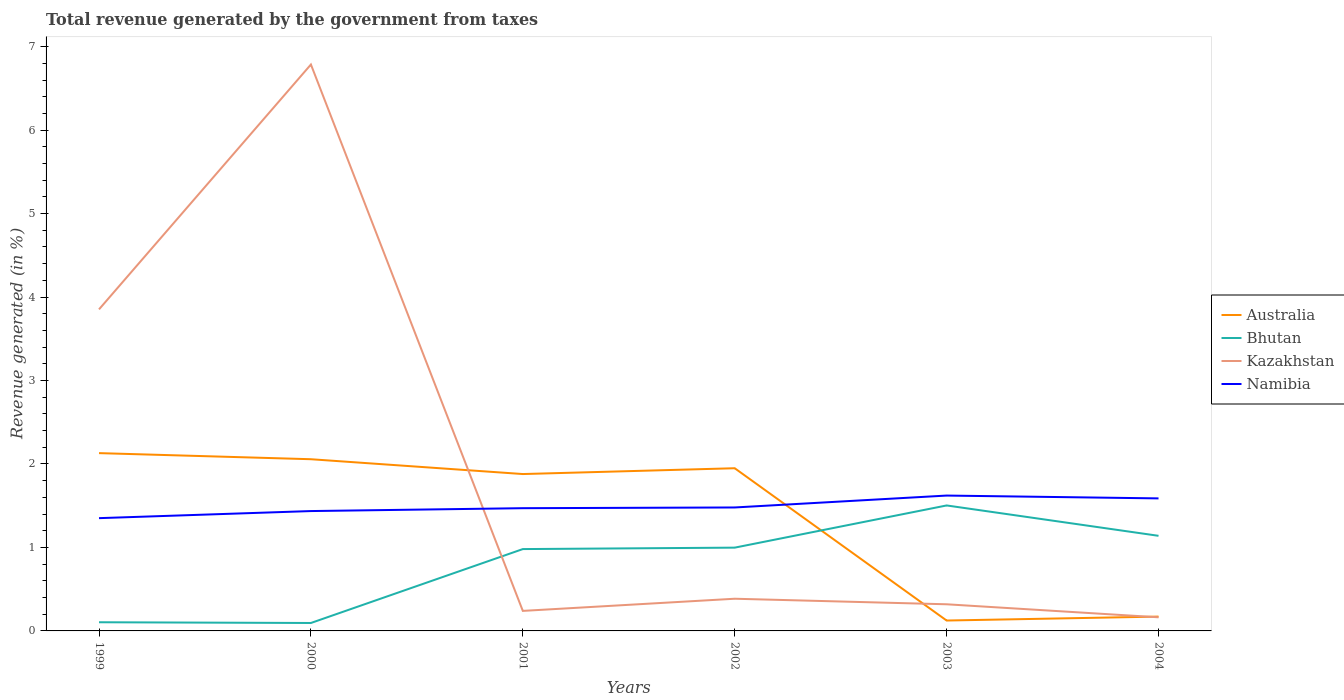Does the line corresponding to Kazakhstan intersect with the line corresponding to Bhutan?
Provide a short and direct response. Yes. Is the number of lines equal to the number of legend labels?
Make the answer very short. Yes. Across all years, what is the maximum total revenue generated in Kazakhstan?
Keep it short and to the point. 0.16. In which year was the total revenue generated in Namibia maximum?
Make the answer very short. 1999. What is the total total revenue generated in Namibia in the graph?
Provide a succinct answer. -0.12. What is the difference between the highest and the second highest total revenue generated in Kazakhstan?
Your answer should be very brief. 6.62. What is the difference between the highest and the lowest total revenue generated in Bhutan?
Offer a terse response. 4. How many lines are there?
Provide a succinct answer. 4. How many years are there in the graph?
Make the answer very short. 6. What is the difference between two consecutive major ticks on the Y-axis?
Offer a very short reply. 1. Are the values on the major ticks of Y-axis written in scientific E-notation?
Your answer should be very brief. No. Does the graph contain any zero values?
Ensure brevity in your answer.  No. Where does the legend appear in the graph?
Offer a terse response. Center right. How many legend labels are there?
Offer a terse response. 4. How are the legend labels stacked?
Your response must be concise. Vertical. What is the title of the graph?
Your answer should be very brief. Total revenue generated by the government from taxes. What is the label or title of the X-axis?
Offer a terse response. Years. What is the label or title of the Y-axis?
Offer a terse response. Revenue generated (in %). What is the Revenue generated (in %) in Australia in 1999?
Ensure brevity in your answer.  2.13. What is the Revenue generated (in %) of Bhutan in 1999?
Your response must be concise. 0.1. What is the Revenue generated (in %) of Kazakhstan in 1999?
Your response must be concise. 3.85. What is the Revenue generated (in %) of Namibia in 1999?
Provide a short and direct response. 1.35. What is the Revenue generated (in %) in Australia in 2000?
Give a very brief answer. 2.06. What is the Revenue generated (in %) of Bhutan in 2000?
Offer a very short reply. 0.1. What is the Revenue generated (in %) in Kazakhstan in 2000?
Keep it short and to the point. 6.79. What is the Revenue generated (in %) in Namibia in 2000?
Your answer should be compact. 1.44. What is the Revenue generated (in %) in Australia in 2001?
Offer a very short reply. 1.88. What is the Revenue generated (in %) of Bhutan in 2001?
Provide a short and direct response. 0.98. What is the Revenue generated (in %) in Kazakhstan in 2001?
Make the answer very short. 0.24. What is the Revenue generated (in %) of Namibia in 2001?
Give a very brief answer. 1.47. What is the Revenue generated (in %) of Australia in 2002?
Provide a succinct answer. 1.95. What is the Revenue generated (in %) of Bhutan in 2002?
Your response must be concise. 1. What is the Revenue generated (in %) of Kazakhstan in 2002?
Give a very brief answer. 0.39. What is the Revenue generated (in %) in Namibia in 2002?
Offer a terse response. 1.48. What is the Revenue generated (in %) of Australia in 2003?
Keep it short and to the point. 0.12. What is the Revenue generated (in %) in Bhutan in 2003?
Give a very brief answer. 1.5. What is the Revenue generated (in %) in Kazakhstan in 2003?
Offer a very short reply. 0.32. What is the Revenue generated (in %) in Namibia in 2003?
Your answer should be very brief. 1.62. What is the Revenue generated (in %) in Australia in 2004?
Provide a succinct answer. 0.17. What is the Revenue generated (in %) of Bhutan in 2004?
Ensure brevity in your answer.  1.14. What is the Revenue generated (in %) in Kazakhstan in 2004?
Provide a succinct answer. 0.16. What is the Revenue generated (in %) of Namibia in 2004?
Give a very brief answer. 1.59. Across all years, what is the maximum Revenue generated (in %) of Australia?
Provide a short and direct response. 2.13. Across all years, what is the maximum Revenue generated (in %) in Bhutan?
Your answer should be very brief. 1.5. Across all years, what is the maximum Revenue generated (in %) of Kazakhstan?
Offer a very short reply. 6.79. Across all years, what is the maximum Revenue generated (in %) in Namibia?
Your answer should be very brief. 1.62. Across all years, what is the minimum Revenue generated (in %) of Australia?
Provide a short and direct response. 0.12. Across all years, what is the minimum Revenue generated (in %) in Bhutan?
Ensure brevity in your answer.  0.1. Across all years, what is the minimum Revenue generated (in %) in Kazakhstan?
Your response must be concise. 0.16. Across all years, what is the minimum Revenue generated (in %) in Namibia?
Offer a very short reply. 1.35. What is the total Revenue generated (in %) in Australia in the graph?
Your answer should be very brief. 8.31. What is the total Revenue generated (in %) in Bhutan in the graph?
Your answer should be compact. 4.82. What is the total Revenue generated (in %) of Kazakhstan in the graph?
Provide a succinct answer. 11.75. What is the total Revenue generated (in %) of Namibia in the graph?
Give a very brief answer. 8.95. What is the difference between the Revenue generated (in %) in Australia in 1999 and that in 2000?
Keep it short and to the point. 0.07. What is the difference between the Revenue generated (in %) of Bhutan in 1999 and that in 2000?
Give a very brief answer. 0.01. What is the difference between the Revenue generated (in %) in Kazakhstan in 1999 and that in 2000?
Give a very brief answer. -2.93. What is the difference between the Revenue generated (in %) in Namibia in 1999 and that in 2000?
Provide a succinct answer. -0.08. What is the difference between the Revenue generated (in %) of Australia in 1999 and that in 2001?
Provide a short and direct response. 0.25. What is the difference between the Revenue generated (in %) in Bhutan in 1999 and that in 2001?
Give a very brief answer. -0.88. What is the difference between the Revenue generated (in %) in Kazakhstan in 1999 and that in 2001?
Your answer should be compact. 3.61. What is the difference between the Revenue generated (in %) in Namibia in 1999 and that in 2001?
Give a very brief answer. -0.12. What is the difference between the Revenue generated (in %) of Australia in 1999 and that in 2002?
Offer a very short reply. 0.18. What is the difference between the Revenue generated (in %) of Bhutan in 1999 and that in 2002?
Offer a terse response. -0.89. What is the difference between the Revenue generated (in %) of Kazakhstan in 1999 and that in 2002?
Your answer should be compact. 3.47. What is the difference between the Revenue generated (in %) in Namibia in 1999 and that in 2002?
Give a very brief answer. -0.13. What is the difference between the Revenue generated (in %) in Australia in 1999 and that in 2003?
Give a very brief answer. 2.01. What is the difference between the Revenue generated (in %) of Bhutan in 1999 and that in 2003?
Ensure brevity in your answer.  -1.4. What is the difference between the Revenue generated (in %) of Kazakhstan in 1999 and that in 2003?
Your answer should be very brief. 3.53. What is the difference between the Revenue generated (in %) in Namibia in 1999 and that in 2003?
Your answer should be very brief. -0.27. What is the difference between the Revenue generated (in %) of Australia in 1999 and that in 2004?
Your answer should be compact. 1.96. What is the difference between the Revenue generated (in %) of Bhutan in 1999 and that in 2004?
Provide a succinct answer. -1.04. What is the difference between the Revenue generated (in %) of Kazakhstan in 1999 and that in 2004?
Make the answer very short. 3.69. What is the difference between the Revenue generated (in %) in Namibia in 1999 and that in 2004?
Offer a very short reply. -0.24. What is the difference between the Revenue generated (in %) in Australia in 2000 and that in 2001?
Provide a short and direct response. 0.18. What is the difference between the Revenue generated (in %) of Bhutan in 2000 and that in 2001?
Ensure brevity in your answer.  -0.89. What is the difference between the Revenue generated (in %) in Kazakhstan in 2000 and that in 2001?
Provide a short and direct response. 6.55. What is the difference between the Revenue generated (in %) of Namibia in 2000 and that in 2001?
Provide a short and direct response. -0.03. What is the difference between the Revenue generated (in %) of Australia in 2000 and that in 2002?
Provide a succinct answer. 0.11. What is the difference between the Revenue generated (in %) in Bhutan in 2000 and that in 2002?
Provide a short and direct response. -0.9. What is the difference between the Revenue generated (in %) in Kazakhstan in 2000 and that in 2002?
Give a very brief answer. 6.4. What is the difference between the Revenue generated (in %) of Namibia in 2000 and that in 2002?
Provide a succinct answer. -0.04. What is the difference between the Revenue generated (in %) in Australia in 2000 and that in 2003?
Keep it short and to the point. 1.93. What is the difference between the Revenue generated (in %) of Bhutan in 2000 and that in 2003?
Offer a very short reply. -1.41. What is the difference between the Revenue generated (in %) of Kazakhstan in 2000 and that in 2003?
Offer a terse response. 6.47. What is the difference between the Revenue generated (in %) of Namibia in 2000 and that in 2003?
Your answer should be compact. -0.19. What is the difference between the Revenue generated (in %) in Australia in 2000 and that in 2004?
Your answer should be compact. 1.89. What is the difference between the Revenue generated (in %) of Bhutan in 2000 and that in 2004?
Keep it short and to the point. -1.04. What is the difference between the Revenue generated (in %) in Kazakhstan in 2000 and that in 2004?
Give a very brief answer. 6.62. What is the difference between the Revenue generated (in %) in Namibia in 2000 and that in 2004?
Keep it short and to the point. -0.15. What is the difference between the Revenue generated (in %) of Australia in 2001 and that in 2002?
Provide a short and direct response. -0.07. What is the difference between the Revenue generated (in %) of Bhutan in 2001 and that in 2002?
Your response must be concise. -0.02. What is the difference between the Revenue generated (in %) in Kazakhstan in 2001 and that in 2002?
Offer a terse response. -0.15. What is the difference between the Revenue generated (in %) in Namibia in 2001 and that in 2002?
Ensure brevity in your answer.  -0.01. What is the difference between the Revenue generated (in %) in Australia in 2001 and that in 2003?
Your answer should be very brief. 1.76. What is the difference between the Revenue generated (in %) of Bhutan in 2001 and that in 2003?
Provide a succinct answer. -0.52. What is the difference between the Revenue generated (in %) in Kazakhstan in 2001 and that in 2003?
Offer a very short reply. -0.08. What is the difference between the Revenue generated (in %) of Namibia in 2001 and that in 2003?
Your answer should be compact. -0.15. What is the difference between the Revenue generated (in %) in Australia in 2001 and that in 2004?
Keep it short and to the point. 1.71. What is the difference between the Revenue generated (in %) of Bhutan in 2001 and that in 2004?
Your response must be concise. -0.16. What is the difference between the Revenue generated (in %) of Kazakhstan in 2001 and that in 2004?
Make the answer very short. 0.08. What is the difference between the Revenue generated (in %) of Namibia in 2001 and that in 2004?
Make the answer very short. -0.12. What is the difference between the Revenue generated (in %) of Australia in 2002 and that in 2003?
Provide a succinct answer. 1.82. What is the difference between the Revenue generated (in %) in Bhutan in 2002 and that in 2003?
Offer a very short reply. -0.51. What is the difference between the Revenue generated (in %) of Kazakhstan in 2002 and that in 2003?
Your response must be concise. 0.07. What is the difference between the Revenue generated (in %) in Namibia in 2002 and that in 2003?
Offer a very short reply. -0.14. What is the difference between the Revenue generated (in %) in Australia in 2002 and that in 2004?
Provide a short and direct response. 1.78. What is the difference between the Revenue generated (in %) of Bhutan in 2002 and that in 2004?
Offer a terse response. -0.14. What is the difference between the Revenue generated (in %) of Kazakhstan in 2002 and that in 2004?
Offer a very short reply. 0.22. What is the difference between the Revenue generated (in %) of Namibia in 2002 and that in 2004?
Make the answer very short. -0.11. What is the difference between the Revenue generated (in %) of Australia in 2003 and that in 2004?
Offer a terse response. -0.05. What is the difference between the Revenue generated (in %) in Bhutan in 2003 and that in 2004?
Ensure brevity in your answer.  0.36. What is the difference between the Revenue generated (in %) in Kazakhstan in 2003 and that in 2004?
Offer a very short reply. 0.16. What is the difference between the Revenue generated (in %) of Namibia in 2003 and that in 2004?
Offer a very short reply. 0.03. What is the difference between the Revenue generated (in %) in Australia in 1999 and the Revenue generated (in %) in Bhutan in 2000?
Offer a very short reply. 2.04. What is the difference between the Revenue generated (in %) in Australia in 1999 and the Revenue generated (in %) in Kazakhstan in 2000?
Offer a terse response. -4.66. What is the difference between the Revenue generated (in %) in Australia in 1999 and the Revenue generated (in %) in Namibia in 2000?
Keep it short and to the point. 0.69. What is the difference between the Revenue generated (in %) of Bhutan in 1999 and the Revenue generated (in %) of Kazakhstan in 2000?
Offer a terse response. -6.68. What is the difference between the Revenue generated (in %) in Bhutan in 1999 and the Revenue generated (in %) in Namibia in 2000?
Give a very brief answer. -1.33. What is the difference between the Revenue generated (in %) in Kazakhstan in 1999 and the Revenue generated (in %) in Namibia in 2000?
Your response must be concise. 2.42. What is the difference between the Revenue generated (in %) of Australia in 1999 and the Revenue generated (in %) of Bhutan in 2001?
Make the answer very short. 1.15. What is the difference between the Revenue generated (in %) of Australia in 1999 and the Revenue generated (in %) of Kazakhstan in 2001?
Ensure brevity in your answer.  1.89. What is the difference between the Revenue generated (in %) of Australia in 1999 and the Revenue generated (in %) of Namibia in 2001?
Make the answer very short. 0.66. What is the difference between the Revenue generated (in %) in Bhutan in 1999 and the Revenue generated (in %) in Kazakhstan in 2001?
Ensure brevity in your answer.  -0.14. What is the difference between the Revenue generated (in %) of Bhutan in 1999 and the Revenue generated (in %) of Namibia in 2001?
Provide a short and direct response. -1.37. What is the difference between the Revenue generated (in %) of Kazakhstan in 1999 and the Revenue generated (in %) of Namibia in 2001?
Provide a short and direct response. 2.38. What is the difference between the Revenue generated (in %) in Australia in 1999 and the Revenue generated (in %) in Bhutan in 2002?
Provide a succinct answer. 1.13. What is the difference between the Revenue generated (in %) of Australia in 1999 and the Revenue generated (in %) of Kazakhstan in 2002?
Offer a very short reply. 1.74. What is the difference between the Revenue generated (in %) in Australia in 1999 and the Revenue generated (in %) in Namibia in 2002?
Make the answer very short. 0.65. What is the difference between the Revenue generated (in %) of Bhutan in 1999 and the Revenue generated (in %) of Kazakhstan in 2002?
Offer a very short reply. -0.28. What is the difference between the Revenue generated (in %) in Bhutan in 1999 and the Revenue generated (in %) in Namibia in 2002?
Your response must be concise. -1.38. What is the difference between the Revenue generated (in %) in Kazakhstan in 1999 and the Revenue generated (in %) in Namibia in 2002?
Your answer should be compact. 2.37. What is the difference between the Revenue generated (in %) of Australia in 1999 and the Revenue generated (in %) of Bhutan in 2003?
Provide a short and direct response. 0.63. What is the difference between the Revenue generated (in %) of Australia in 1999 and the Revenue generated (in %) of Kazakhstan in 2003?
Your answer should be compact. 1.81. What is the difference between the Revenue generated (in %) in Australia in 1999 and the Revenue generated (in %) in Namibia in 2003?
Offer a very short reply. 0.51. What is the difference between the Revenue generated (in %) in Bhutan in 1999 and the Revenue generated (in %) in Kazakhstan in 2003?
Your response must be concise. -0.22. What is the difference between the Revenue generated (in %) in Bhutan in 1999 and the Revenue generated (in %) in Namibia in 2003?
Your response must be concise. -1.52. What is the difference between the Revenue generated (in %) in Kazakhstan in 1999 and the Revenue generated (in %) in Namibia in 2003?
Provide a succinct answer. 2.23. What is the difference between the Revenue generated (in %) of Australia in 1999 and the Revenue generated (in %) of Bhutan in 2004?
Give a very brief answer. 0.99. What is the difference between the Revenue generated (in %) of Australia in 1999 and the Revenue generated (in %) of Kazakhstan in 2004?
Make the answer very short. 1.97. What is the difference between the Revenue generated (in %) of Australia in 1999 and the Revenue generated (in %) of Namibia in 2004?
Provide a short and direct response. 0.54. What is the difference between the Revenue generated (in %) in Bhutan in 1999 and the Revenue generated (in %) in Kazakhstan in 2004?
Ensure brevity in your answer.  -0.06. What is the difference between the Revenue generated (in %) in Bhutan in 1999 and the Revenue generated (in %) in Namibia in 2004?
Provide a succinct answer. -1.48. What is the difference between the Revenue generated (in %) in Kazakhstan in 1999 and the Revenue generated (in %) in Namibia in 2004?
Make the answer very short. 2.26. What is the difference between the Revenue generated (in %) in Australia in 2000 and the Revenue generated (in %) in Bhutan in 2001?
Your response must be concise. 1.08. What is the difference between the Revenue generated (in %) of Australia in 2000 and the Revenue generated (in %) of Kazakhstan in 2001?
Your answer should be very brief. 1.82. What is the difference between the Revenue generated (in %) in Australia in 2000 and the Revenue generated (in %) in Namibia in 2001?
Offer a terse response. 0.59. What is the difference between the Revenue generated (in %) of Bhutan in 2000 and the Revenue generated (in %) of Kazakhstan in 2001?
Provide a succinct answer. -0.14. What is the difference between the Revenue generated (in %) of Bhutan in 2000 and the Revenue generated (in %) of Namibia in 2001?
Give a very brief answer. -1.38. What is the difference between the Revenue generated (in %) in Kazakhstan in 2000 and the Revenue generated (in %) in Namibia in 2001?
Provide a short and direct response. 5.32. What is the difference between the Revenue generated (in %) in Australia in 2000 and the Revenue generated (in %) in Bhutan in 2002?
Your response must be concise. 1.06. What is the difference between the Revenue generated (in %) of Australia in 2000 and the Revenue generated (in %) of Kazakhstan in 2002?
Your answer should be very brief. 1.67. What is the difference between the Revenue generated (in %) in Australia in 2000 and the Revenue generated (in %) in Namibia in 2002?
Give a very brief answer. 0.58. What is the difference between the Revenue generated (in %) in Bhutan in 2000 and the Revenue generated (in %) in Kazakhstan in 2002?
Your response must be concise. -0.29. What is the difference between the Revenue generated (in %) of Bhutan in 2000 and the Revenue generated (in %) of Namibia in 2002?
Provide a succinct answer. -1.38. What is the difference between the Revenue generated (in %) of Kazakhstan in 2000 and the Revenue generated (in %) of Namibia in 2002?
Your response must be concise. 5.31. What is the difference between the Revenue generated (in %) of Australia in 2000 and the Revenue generated (in %) of Bhutan in 2003?
Make the answer very short. 0.55. What is the difference between the Revenue generated (in %) in Australia in 2000 and the Revenue generated (in %) in Kazakhstan in 2003?
Give a very brief answer. 1.74. What is the difference between the Revenue generated (in %) of Australia in 2000 and the Revenue generated (in %) of Namibia in 2003?
Ensure brevity in your answer.  0.44. What is the difference between the Revenue generated (in %) in Bhutan in 2000 and the Revenue generated (in %) in Kazakhstan in 2003?
Keep it short and to the point. -0.22. What is the difference between the Revenue generated (in %) of Bhutan in 2000 and the Revenue generated (in %) of Namibia in 2003?
Your answer should be very brief. -1.53. What is the difference between the Revenue generated (in %) in Kazakhstan in 2000 and the Revenue generated (in %) in Namibia in 2003?
Your response must be concise. 5.16. What is the difference between the Revenue generated (in %) of Australia in 2000 and the Revenue generated (in %) of Bhutan in 2004?
Provide a short and direct response. 0.92. What is the difference between the Revenue generated (in %) in Australia in 2000 and the Revenue generated (in %) in Kazakhstan in 2004?
Your response must be concise. 1.89. What is the difference between the Revenue generated (in %) of Australia in 2000 and the Revenue generated (in %) of Namibia in 2004?
Offer a terse response. 0.47. What is the difference between the Revenue generated (in %) in Bhutan in 2000 and the Revenue generated (in %) in Kazakhstan in 2004?
Ensure brevity in your answer.  -0.07. What is the difference between the Revenue generated (in %) in Bhutan in 2000 and the Revenue generated (in %) in Namibia in 2004?
Provide a short and direct response. -1.49. What is the difference between the Revenue generated (in %) of Kazakhstan in 2000 and the Revenue generated (in %) of Namibia in 2004?
Make the answer very short. 5.2. What is the difference between the Revenue generated (in %) in Australia in 2001 and the Revenue generated (in %) in Bhutan in 2002?
Keep it short and to the point. 0.88. What is the difference between the Revenue generated (in %) in Australia in 2001 and the Revenue generated (in %) in Kazakhstan in 2002?
Make the answer very short. 1.49. What is the difference between the Revenue generated (in %) of Australia in 2001 and the Revenue generated (in %) of Namibia in 2002?
Offer a very short reply. 0.4. What is the difference between the Revenue generated (in %) of Bhutan in 2001 and the Revenue generated (in %) of Kazakhstan in 2002?
Make the answer very short. 0.59. What is the difference between the Revenue generated (in %) in Bhutan in 2001 and the Revenue generated (in %) in Namibia in 2002?
Ensure brevity in your answer.  -0.5. What is the difference between the Revenue generated (in %) in Kazakhstan in 2001 and the Revenue generated (in %) in Namibia in 2002?
Give a very brief answer. -1.24. What is the difference between the Revenue generated (in %) of Australia in 2001 and the Revenue generated (in %) of Bhutan in 2003?
Offer a terse response. 0.38. What is the difference between the Revenue generated (in %) in Australia in 2001 and the Revenue generated (in %) in Kazakhstan in 2003?
Give a very brief answer. 1.56. What is the difference between the Revenue generated (in %) in Australia in 2001 and the Revenue generated (in %) in Namibia in 2003?
Make the answer very short. 0.26. What is the difference between the Revenue generated (in %) in Bhutan in 2001 and the Revenue generated (in %) in Kazakhstan in 2003?
Your answer should be compact. 0.66. What is the difference between the Revenue generated (in %) of Bhutan in 2001 and the Revenue generated (in %) of Namibia in 2003?
Provide a short and direct response. -0.64. What is the difference between the Revenue generated (in %) in Kazakhstan in 2001 and the Revenue generated (in %) in Namibia in 2003?
Offer a very short reply. -1.38. What is the difference between the Revenue generated (in %) in Australia in 2001 and the Revenue generated (in %) in Bhutan in 2004?
Your answer should be very brief. 0.74. What is the difference between the Revenue generated (in %) in Australia in 2001 and the Revenue generated (in %) in Kazakhstan in 2004?
Offer a very short reply. 1.72. What is the difference between the Revenue generated (in %) in Australia in 2001 and the Revenue generated (in %) in Namibia in 2004?
Offer a terse response. 0.29. What is the difference between the Revenue generated (in %) of Bhutan in 2001 and the Revenue generated (in %) of Kazakhstan in 2004?
Provide a short and direct response. 0.82. What is the difference between the Revenue generated (in %) of Bhutan in 2001 and the Revenue generated (in %) of Namibia in 2004?
Offer a very short reply. -0.61. What is the difference between the Revenue generated (in %) of Kazakhstan in 2001 and the Revenue generated (in %) of Namibia in 2004?
Offer a very short reply. -1.35. What is the difference between the Revenue generated (in %) in Australia in 2002 and the Revenue generated (in %) in Bhutan in 2003?
Your answer should be very brief. 0.45. What is the difference between the Revenue generated (in %) of Australia in 2002 and the Revenue generated (in %) of Kazakhstan in 2003?
Your answer should be very brief. 1.63. What is the difference between the Revenue generated (in %) in Australia in 2002 and the Revenue generated (in %) in Namibia in 2003?
Offer a terse response. 0.33. What is the difference between the Revenue generated (in %) of Bhutan in 2002 and the Revenue generated (in %) of Kazakhstan in 2003?
Offer a very short reply. 0.68. What is the difference between the Revenue generated (in %) in Bhutan in 2002 and the Revenue generated (in %) in Namibia in 2003?
Your response must be concise. -0.62. What is the difference between the Revenue generated (in %) in Kazakhstan in 2002 and the Revenue generated (in %) in Namibia in 2003?
Offer a very short reply. -1.24. What is the difference between the Revenue generated (in %) in Australia in 2002 and the Revenue generated (in %) in Bhutan in 2004?
Give a very brief answer. 0.81. What is the difference between the Revenue generated (in %) in Australia in 2002 and the Revenue generated (in %) in Kazakhstan in 2004?
Keep it short and to the point. 1.79. What is the difference between the Revenue generated (in %) of Australia in 2002 and the Revenue generated (in %) of Namibia in 2004?
Give a very brief answer. 0.36. What is the difference between the Revenue generated (in %) in Bhutan in 2002 and the Revenue generated (in %) in Kazakhstan in 2004?
Make the answer very short. 0.83. What is the difference between the Revenue generated (in %) of Bhutan in 2002 and the Revenue generated (in %) of Namibia in 2004?
Offer a terse response. -0.59. What is the difference between the Revenue generated (in %) of Kazakhstan in 2002 and the Revenue generated (in %) of Namibia in 2004?
Provide a succinct answer. -1.2. What is the difference between the Revenue generated (in %) of Australia in 2003 and the Revenue generated (in %) of Bhutan in 2004?
Offer a terse response. -1.02. What is the difference between the Revenue generated (in %) in Australia in 2003 and the Revenue generated (in %) in Kazakhstan in 2004?
Provide a short and direct response. -0.04. What is the difference between the Revenue generated (in %) in Australia in 2003 and the Revenue generated (in %) in Namibia in 2004?
Offer a terse response. -1.46. What is the difference between the Revenue generated (in %) in Bhutan in 2003 and the Revenue generated (in %) in Kazakhstan in 2004?
Your answer should be compact. 1.34. What is the difference between the Revenue generated (in %) of Bhutan in 2003 and the Revenue generated (in %) of Namibia in 2004?
Make the answer very short. -0.08. What is the difference between the Revenue generated (in %) in Kazakhstan in 2003 and the Revenue generated (in %) in Namibia in 2004?
Your response must be concise. -1.27. What is the average Revenue generated (in %) in Australia per year?
Your answer should be very brief. 1.39. What is the average Revenue generated (in %) of Bhutan per year?
Ensure brevity in your answer.  0.8. What is the average Revenue generated (in %) in Kazakhstan per year?
Offer a terse response. 1.96. What is the average Revenue generated (in %) in Namibia per year?
Keep it short and to the point. 1.49. In the year 1999, what is the difference between the Revenue generated (in %) in Australia and Revenue generated (in %) in Bhutan?
Provide a succinct answer. 2.03. In the year 1999, what is the difference between the Revenue generated (in %) of Australia and Revenue generated (in %) of Kazakhstan?
Your response must be concise. -1.72. In the year 1999, what is the difference between the Revenue generated (in %) of Australia and Revenue generated (in %) of Namibia?
Your response must be concise. 0.78. In the year 1999, what is the difference between the Revenue generated (in %) of Bhutan and Revenue generated (in %) of Kazakhstan?
Provide a short and direct response. -3.75. In the year 1999, what is the difference between the Revenue generated (in %) of Bhutan and Revenue generated (in %) of Namibia?
Your answer should be compact. -1.25. In the year 1999, what is the difference between the Revenue generated (in %) of Kazakhstan and Revenue generated (in %) of Namibia?
Your answer should be very brief. 2.5. In the year 2000, what is the difference between the Revenue generated (in %) in Australia and Revenue generated (in %) in Bhutan?
Offer a very short reply. 1.96. In the year 2000, what is the difference between the Revenue generated (in %) in Australia and Revenue generated (in %) in Kazakhstan?
Ensure brevity in your answer.  -4.73. In the year 2000, what is the difference between the Revenue generated (in %) of Australia and Revenue generated (in %) of Namibia?
Make the answer very short. 0.62. In the year 2000, what is the difference between the Revenue generated (in %) in Bhutan and Revenue generated (in %) in Kazakhstan?
Your response must be concise. -6.69. In the year 2000, what is the difference between the Revenue generated (in %) of Bhutan and Revenue generated (in %) of Namibia?
Provide a succinct answer. -1.34. In the year 2000, what is the difference between the Revenue generated (in %) of Kazakhstan and Revenue generated (in %) of Namibia?
Offer a very short reply. 5.35. In the year 2001, what is the difference between the Revenue generated (in %) of Australia and Revenue generated (in %) of Bhutan?
Provide a succinct answer. 0.9. In the year 2001, what is the difference between the Revenue generated (in %) of Australia and Revenue generated (in %) of Kazakhstan?
Ensure brevity in your answer.  1.64. In the year 2001, what is the difference between the Revenue generated (in %) in Australia and Revenue generated (in %) in Namibia?
Your response must be concise. 0.41. In the year 2001, what is the difference between the Revenue generated (in %) of Bhutan and Revenue generated (in %) of Kazakhstan?
Your answer should be very brief. 0.74. In the year 2001, what is the difference between the Revenue generated (in %) of Bhutan and Revenue generated (in %) of Namibia?
Make the answer very short. -0.49. In the year 2001, what is the difference between the Revenue generated (in %) of Kazakhstan and Revenue generated (in %) of Namibia?
Make the answer very short. -1.23. In the year 2002, what is the difference between the Revenue generated (in %) of Australia and Revenue generated (in %) of Bhutan?
Provide a short and direct response. 0.95. In the year 2002, what is the difference between the Revenue generated (in %) in Australia and Revenue generated (in %) in Kazakhstan?
Your answer should be compact. 1.56. In the year 2002, what is the difference between the Revenue generated (in %) of Australia and Revenue generated (in %) of Namibia?
Your response must be concise. 0.47. In the year 2002, what is the difference between the Revenue generated (in %) in Bhutan and Revenue generated (in %) in Kazakhstan?
Make the answer very short. 0.61. In the year 2002, what is the difference between the Revenue generated (in %) in Bhutan and Revenue generated (in %) in Namibia?
Give a very brief answer. -0.48. In the year 2002, what is the difference between the Revenue generated (in %) of Kazakhstan and Revenue generated (in %) of Namibia?
Provide a short and direct response. -1.09. In the year 2003, what is the difference between the Revenue generated (in %) in Australia and Revenue generated (in %) in Bhutan?
Your answer should be very brief. -1.38. In the year 2003, what is the difference between the Revenue generated (in %) in Australia and Revenue generated (in %) in Kazakhstan?
Offer a very short reply. -0.19. In the year 2003, what is the difference between the Revenue generated (in %) of Australia and Revenue generated (in %) of Namibia?
Your response must be concise. -1.5. In the year 2003, what is the difference between the Revenue generated (in %) of Bhutan and Revenue generated (in %) of Kazakhstan?
Ensure brevity in your answer.  1.18. In the year 2003, what is the difference between the Revenue generated (in %) in Bhutan and Revenue generated (in %) in Namibia?
Your answer should be compact. -0.12. In the year 2003, what is the difference between the Revenue generated (in %) in Kazakhstan and Revenue generated (in %) in Namibia?
Give a very brief answer. -1.3. In the year 2004, what is the difference between the Revenue generated (in %) of Australia and Revenue generated (in %) of Bhutan?
Ensure brevity in your answer.  -0.97. In the year 2004, what is the difference between the Revenue generated (in %) of Australia and Revenue generated (in %) of Kazakhstan?
Make the answer very short. 0.01. In the year 2004, what is the difference between the Revenue generated (in %) in Australia and Revenue generated (in %) in Namibia?
Your answer should be compact. -1.42. In the year 2004, what is the difference between the Revenue generated (in %) in Bhutan and Revenue generated (in %) in Kazakhstan?
Your response must be concise. 0.98. In the year 2004, what is the difference between the Revenue generated (in %) of Bhutan and Revenue generated (in %) of Namibia?
Offer a terse response. -0.45. In the year 2004, what is the difference between the Revenue generated (in %) of Kazakhstan and Revenue generated (in %) of Namibia?
Keep it short and to the point. -1.42. What is the ratio of the Revenue generated (in %) of Australia in 1999 to that in 2000?
Give a very brief answer. 1.04. What is the ratio of the Revenue generated (in %) of Bhutan in 1999 to that in 2000?
Offer a very short reply. 1.09. What is the ratio of the Revenue generated (in %) of Kazakhstan in 1999 to that in 2000?
Make the answer very short. 0.57. What is the ratio of the Revenue generated (in %) of Namibia in 1999 to that in 2000?
Keep it short and to the point. 0.94. What is the ratio of the Revenue generated (in %) of Australia in 1999 to that in 2001?
Your answer should be compact. 1.13. What is the ratio of the Revenue generated (in %) in Bhutan in 1999 to that in 2001?
Your response must be concise. 0.11. What is the ratio of the Revenue generated (in %) of Kazakhstan in 1999 to that in 2001?
Your answer should be compact. 16.05. What is the ratio of the Revenue generated (in %) of Namibia in 1999 to that in 2001?
Provide a short and direct response. 0.92. What is the ratio of the Revenue generated (in %) of Australia in 1999 to that in 2002?
Keep it short and to the point. 1.09. What is the ratio of the Revenue generated (in %) of Bhutan in 1999 to that in 2002?
Ensure brevity in your answer.  0.1. What is the ratio of the Revenue generated (in %) of Kazakhstan in 1999 to that in 2002?
Ensure brevity in your answer.  9.99. What is the ratio of the Revenue generated (in %) of Namibia in 1999 to that in 2002?
Your answer should be very brief. 0.91. What is the ratio of the Revenue generated (in %) in Australia in 1999 to that in 2003?
Your answer should be very brief. 17.12. What is the ratio of the Revenue generated (in %) of Bhutan in 1999 to that in 2003?
Make the answer very short. 0.07. What is the ratio of the Revenue generated (in %) of Kazakhstan in 1999 to that in 2003?
Make the answer very short. 12.07. What is the ratio of the Revenue generated (in %) in Namibia in 1999 to that in 2003?
Provide a succinct answer. 0.83. What is the ratio of the Revenue generated (in %) in Australia in 1999 to that in 2004?
Make the answer very short. 12.41. What is the ratio of the Revenue generated (in %) of Bhutan in 1999 to that in 2004?
Keep it short and to the point. 0.09. What is the ratio of the Revenue generated (in %) in Kazakhstan in 1999 to that in 2004?
Make the answer very short. 23.6. What is the ratio of the Revenue generated (in %) of Namibia in 1999 to that in 2004?
Your response must be concise. 0.85. What is the ratio of the Revenue generated (in %) in Australia in 2000 to that in 2001?
Provide a succinct answer. 1.09. What is the ratio of the Revenue generated (in %) in Bhutan in 2000 to that in 2001?
Provide a short and direct response. 0.1. What is the ratio of the Revenue generated (in %) in Kazakhstan in 2000 to that in 2001?
Provide a succinct answer. 28.27. What is the ratio of the Revenue generated (in %) in Namibia in 2000 to that in 2001?
Offer a terse response. 0.98. What is the ratio of the Revenue generated (in %) in Australia in 2000 to that in 2002?
Ensure brevity in your answer.  1.06. What is the ratio of the Revenue generated (in %) in Bhutan in 2000 to that in 2002?
Give a very brief answer. 0.1. What is the ratio of the Revenue generated (in %) of Kazakhstan in 2000 to that in 2002?
Offer a terse response. 17.6. What is the ratio of the Revenue generated (in %) in Namibia in 2000 to that in 2002?
Offer a very short reply. 0.97. What is the ratio of the Revenue generated (in %) of Australia in 2000 to that in 2003?
Provide a succinct answer. 16.53. What is the ratio of the Revenue generated (in %) in Bhutan in 2000 to that in 2003?
Provide a short and direct response. 0.06. What is the ratio of the Revenue generated (in %) of Kazakhstan in 2000 to that in 2003?
Provide a short and direct response. 21.26. What is the ratio of the Revenue generated (in %) of Namibia in 2000 to that in 2003?
Offer a very short reply. 0.89. What is the ratio of the Revenue generated (in %) in Australia in 2000 to that in 2004?
Provide a short and direct response. 11.98. What is the ratio of the Revenue generated (in %) in Bhutan in 2000 to that in 2004?
Your response must be concise. 0.08. What is the ratio of the Revenue generated (in %) of Kazakhstan in 2000 to that in 2004?
Offer a terse response. 41.58. What is the ratio of the Revenue generated (in %) of Namibia in 2000 to that in 2004?
Give a very brief answer. 0.9. What is the ratio of the Revenue generated (in %) in Bhutan in 2001 to that in 2002?
Provide a succinct answer. 0.98. What is the ratio of the Revenue generated (in %) of Kazakhstan in 2001 to that in 2002?
Keep it short and to the point. 0.62. What is the ratio of the Revenue generated (in %) in Namibia in 2001 to that in 2002?
Your response must be concise. 0.99. What is the ratio of the Revenue generated (in %) of Australia in 2001 to that in 2003?
Make the answer very short. 15.11. What is the ratio of the Revenue generated (in %) in Bhutan in 2001 to that in 2003?
Offer a terse response. 0.65. What is the ratio of the Revenue generated (in %) of Kazakhstan in 2001 to that in 2003?
Your answer should be compact. 0.75. What is the ratio of the Revenue generated (in %) in Namibia in 2001 to that in 2003?
Your answer should be compact. 0.91. What is the ratio of the Revenue generated (in %) in Australia in 2001 to that in 2004?
Keep it short and to the point. 10.95. What is the ratio of the Revenue generated (in %) in Bhutan in 2001 to that in 2004?
Keep it short and to the point. 0.86. What is the ratio of the Revenue generated (in %) of Kazakhstan in 2001 to that in 2004?
Ensure brevity in your answer.  1.47. What is the ratio of the Revenue generated (in %) in Namibia in 2001 to that in 2004?
Make the answer very short. 0.93. What is the ratio of the Revenue generated (in %) of Australia in 2002 to that in 2003?
Ensure brevity in your answer.  15.67. What is the ratio of the Revenue generated (in %) in Bhutan in 2002 to that in 2003?
Ensure brevity in your answer.  0.66. What is the ratio of the Revenue generated (in %) of Kazakhstan in 2002 to that in 2003?
Provide a short and direct response. 1.21. What is the ratio of the Revenue generated (in %) of Namibia in 2002 to that in 2003?
Your response must be concise. 0.91. What is the ratio of the Revenue generated (in %) of Australia in 2002 to that in 2004?
Offer a terse response. 11.35. What is the ratio of the Revenue generated (in %) in Bhutan in 2002 to that in 2004?
Ensure brevity in your answer.  0.88. What is the ratio of the Revenue generated (in %) in Kazakhstan in 2002 to that in 2004?
Give a very brief answer. 2.36. What is the ratio of the Revenue generated (in %) of Namibia in 2002 to that in 2004?
Your answer should be compact. 0.93. What is the ratio of the Revenue generated (in %) of Australia in 2003 to that in 2004?
Provide a succinct answer. 0.72. What is the ratio of the Revenue generated (in %) of Bhutan in 2003 to that in 2004?
Your answer should be compact. 1.32. What is the ratio of the Revenue generated (in %) of Kazakhstan in 2003 to that in 2004?
Make the answer very short. 1.96. What is the ratio of the Revenue generated (in %) of Namibia in 2003 to that in 2004?
Provide a short and direct response. 1.02. What is the difference between the highest and the second highest Revenue generated (in %) of Australia?
Keep it short and to the point. 0.07. What is the difference between the highest and the second highest Revenue generated (in %) in Bhutan?
Your answer should be very brief. 0.36. What is the difference between the highest and the second highest Revenue generated (in %) in Kazakhstan?
Ensure brevity in your answer.  2.93. What is the difference between the highest and the second highest Revenue generated (in %) in Namibia?
Provide a succinct answer. 0.03. What is the difference between the highest and the lowest Revenue generated (in %) of Australia?
Provide a short and direct response. 2.01. What is the difference between the highest and the lowest Revenue generated (in %) in Bhutan?
Keep it short and to the point. 1.41. What is the difference between the highest and the lowest Revenue generated (in %) of Kazakhstan?
Your response must be concise. 6.62. What is the difference between the highest and the lowest Revenue generated (in %) of Namibia?
Your answer should be compact. 0.27. 